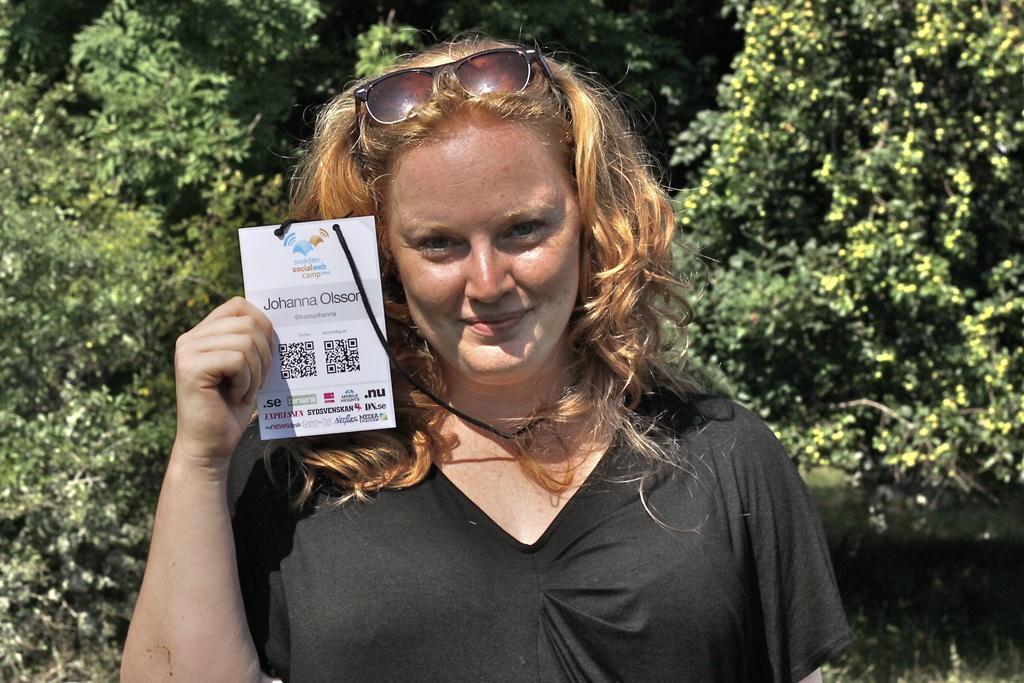Can you describe this image briefly? In this image we can see a woman is holding a card in her hand and there is a google on her head. In the background there are trees. 